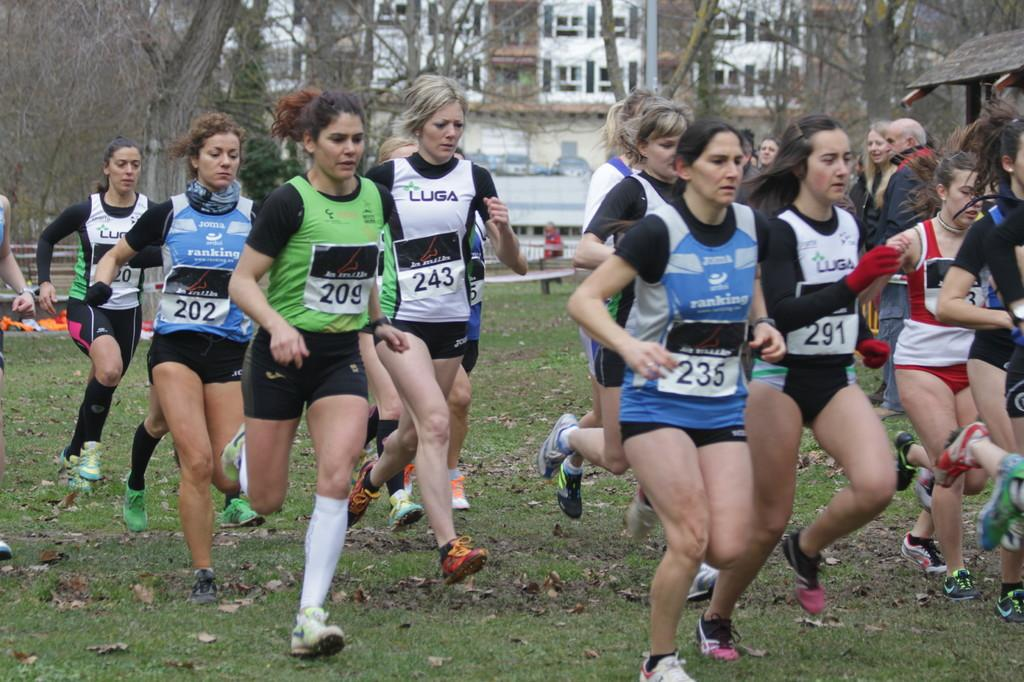Provide a one-sentence caption for the provided image. Runner 291 and 243 have been sponsored by LUGA. 